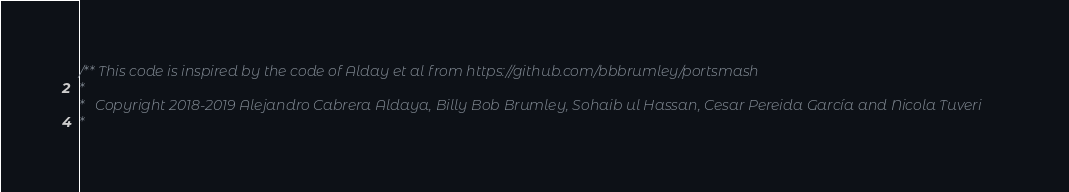Convert code to text. <code><loc_0><loc_0><loc_500><loc_500><_C_>/** This code is inspired by the code of Alday et al from https://github.com/bbbrumley/portsmash
*
*   Copyright 2018-2019 Alejandro Cabrera Aldaya, Billy Bob Brumley, Sohaib ul Hassan, Cesar Pereida García and Nicola Tuveri
*</code> 